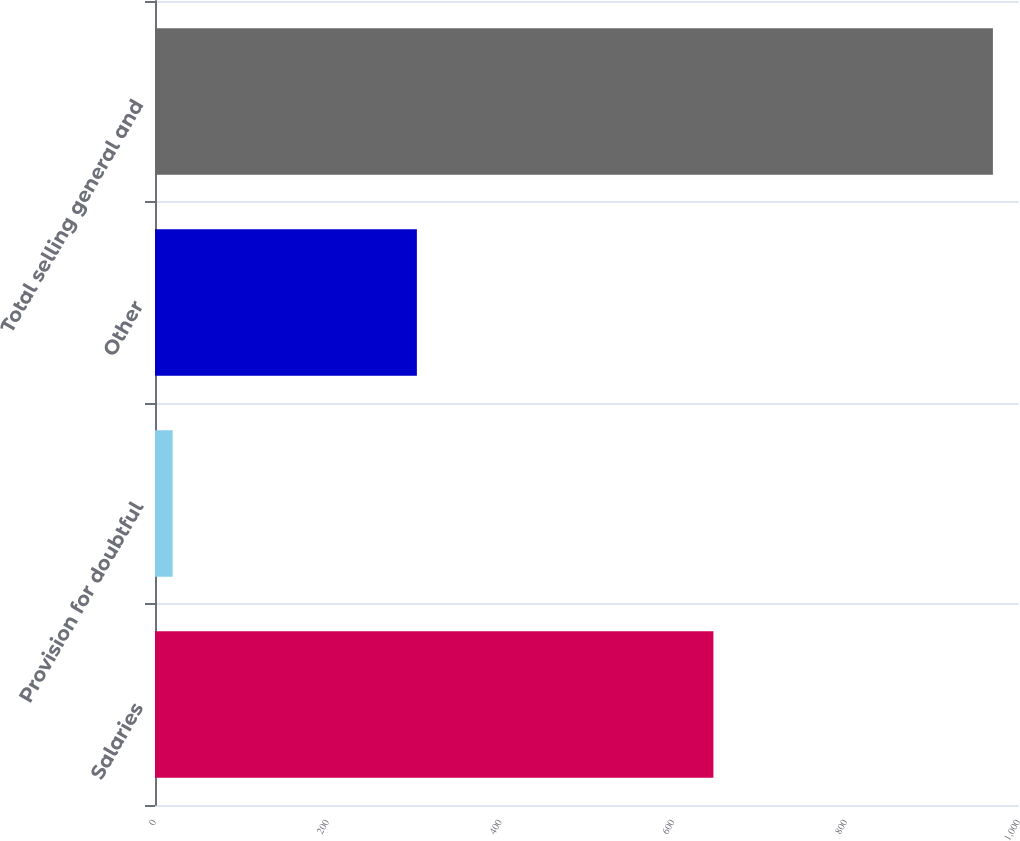Convert chart to OTSL. <chart><loc_0><loc_0><loc_500><loc_500><bar_chart><fcel>Salaries<fcel>Provision for doubtful<fcel>Other<fcel>Total selling general and<nl><fcel>646.3<fcel>20.4<fcel>303.1<fcel>969.8<nl></chart> 